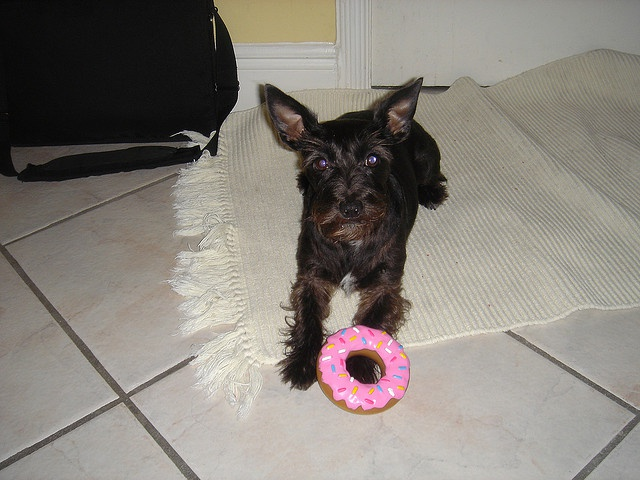Describe the objects in this image and their specific colors. I can see handbag in black, gray, and darkgray tones, backpack in black, gray, and darkgray tones, dog in black, gray, and maroon tones, and donut in black, violet, lightpink, and brown tones in this image. 